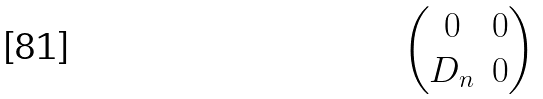<formula> <loc_0><loc_0><loc_500><loc_500>\begin{pmatrix} 0 & 0 \\ D _ { n } & 0 \end{pmatrix}</formula> 